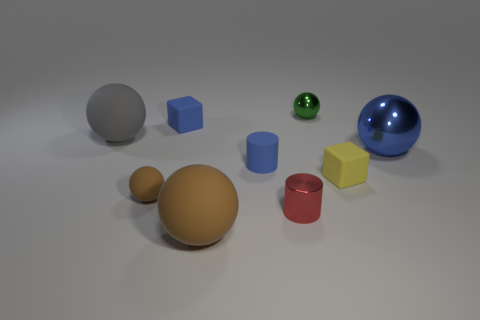Add 1 green metallic spheres. How many objects exist? 10 Subtract all matte spheres. How many spheres are left? 2 Subtract 1 cubes. How many cubes are left? 1 Subtract all cylinders. How many objects are left? 7 Subtract all blue cylinders. How many brown spheres are left? 2 Subtract 1 red cylinders. How many objects are left? 8 Subtract all gray spheres. Subtract all cyan cylinders. How many spheres are left? 4 Subtract all tiny yellow matte objects. Subtract all small red metal cylinders. How many objects are left? 7 Add 2 small shiny balls. How many small shiny balls are left? 3 Add 1 purple blocks. How many purple blocks exist? 1 